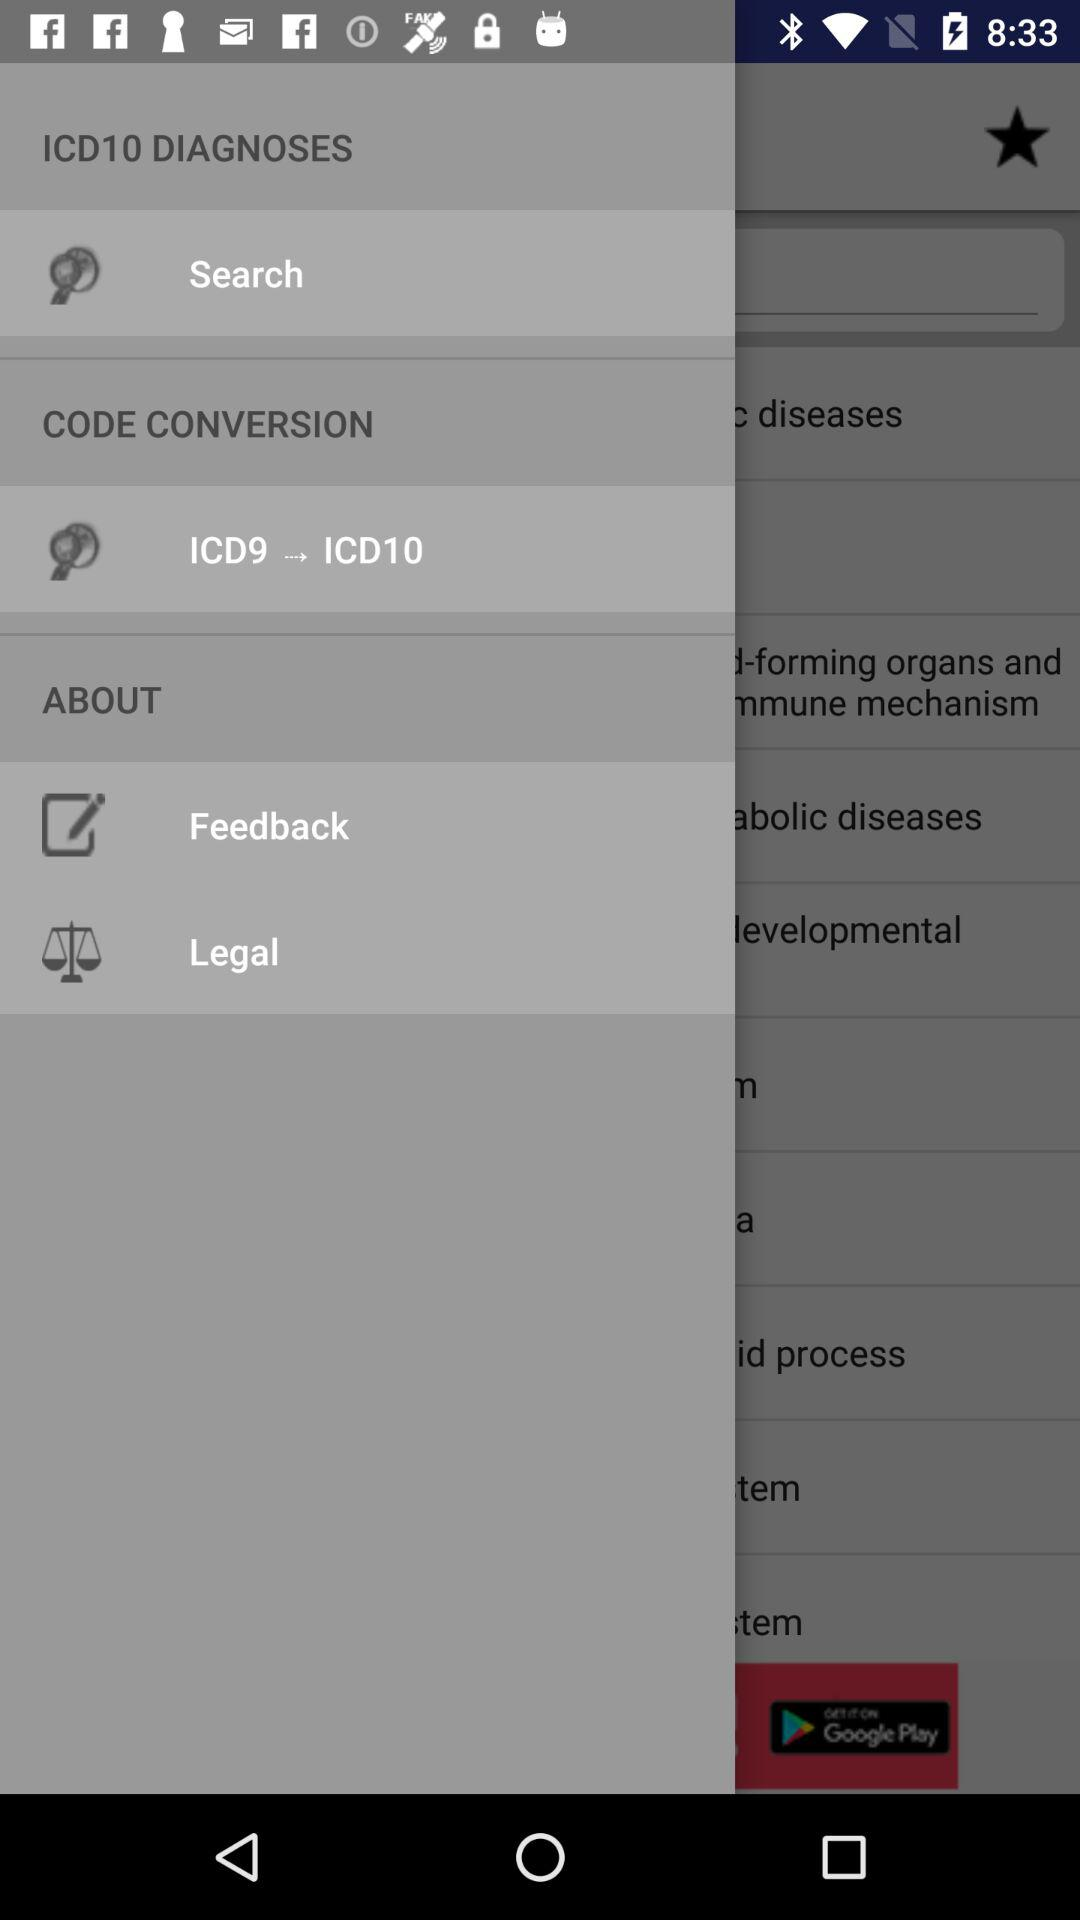How many notifications are there in "Search"?
When the provided information is insufficient, respond with <no answer>. <no answer> 